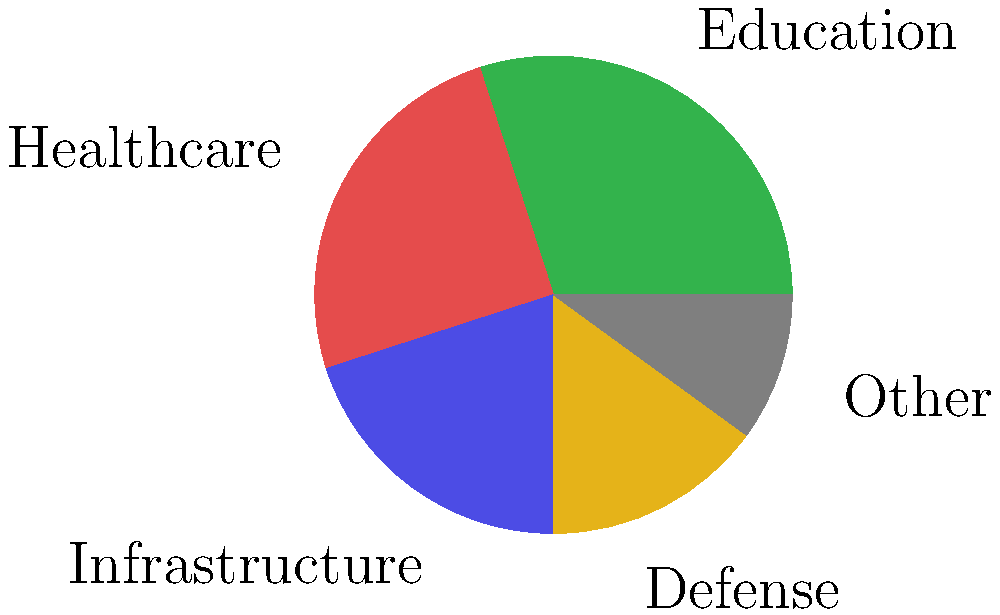As a legislator analyzing the current budget allocation, you notice that the combined percentage for Education and Healthcare exceeds that of Infrastructure and Defense together. By what percentage does this difference amount to? To solve this problem, we need to follow these steps:

1. Identify the percentages for Education and Healthcare:
   Education: 30%
   Healthcare: 25%

2. Calculate the sum of Education and Healthcare:
   $30\% + 25\% = 55\%$

3. Identify the percentages for Infrastructure and Defense:
   Infrastructure: 20%
   Defense: 15%

4. Calculate the sum of Infrastructure and Defense:
   $20\% + 15\% = 35\%$

5. Calculate the difference between the two sums:
   $55\% - 35\% = 20\%$

Therefore, the combined percentage for Education and Healthcare exceeds that of Infrastructure and Defense by 20%.
Answer: 20% 